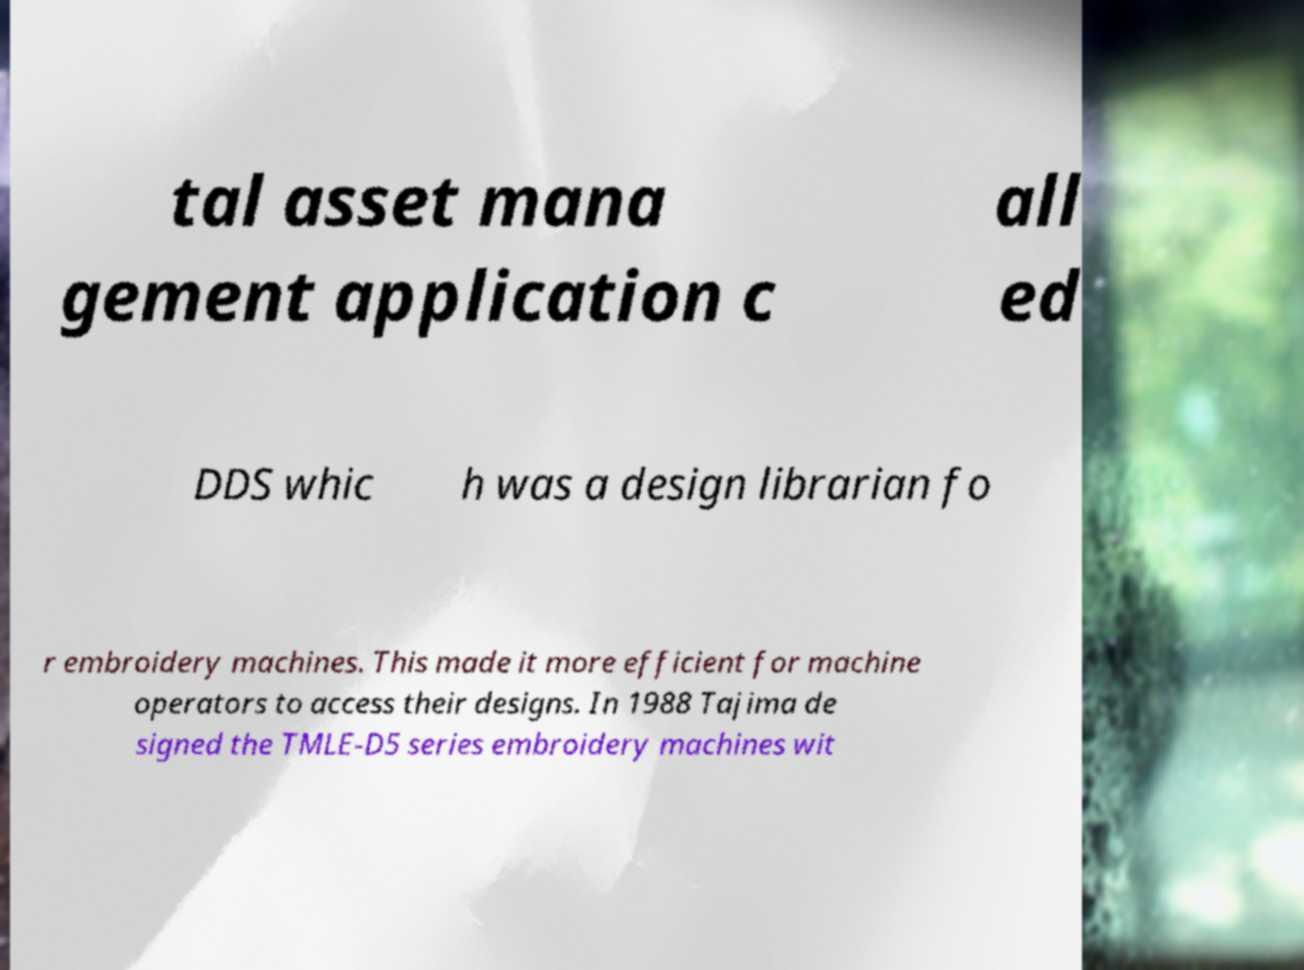Could you extract and type out the text from this image? tal asset mana gement application c all ed DDS whic h was a design librarian fo r embroidery machines. This made it more efficient for machine operators to access their designs. In 1988 Tajima de signed the TMLE-D5 series embroidery machines wit 